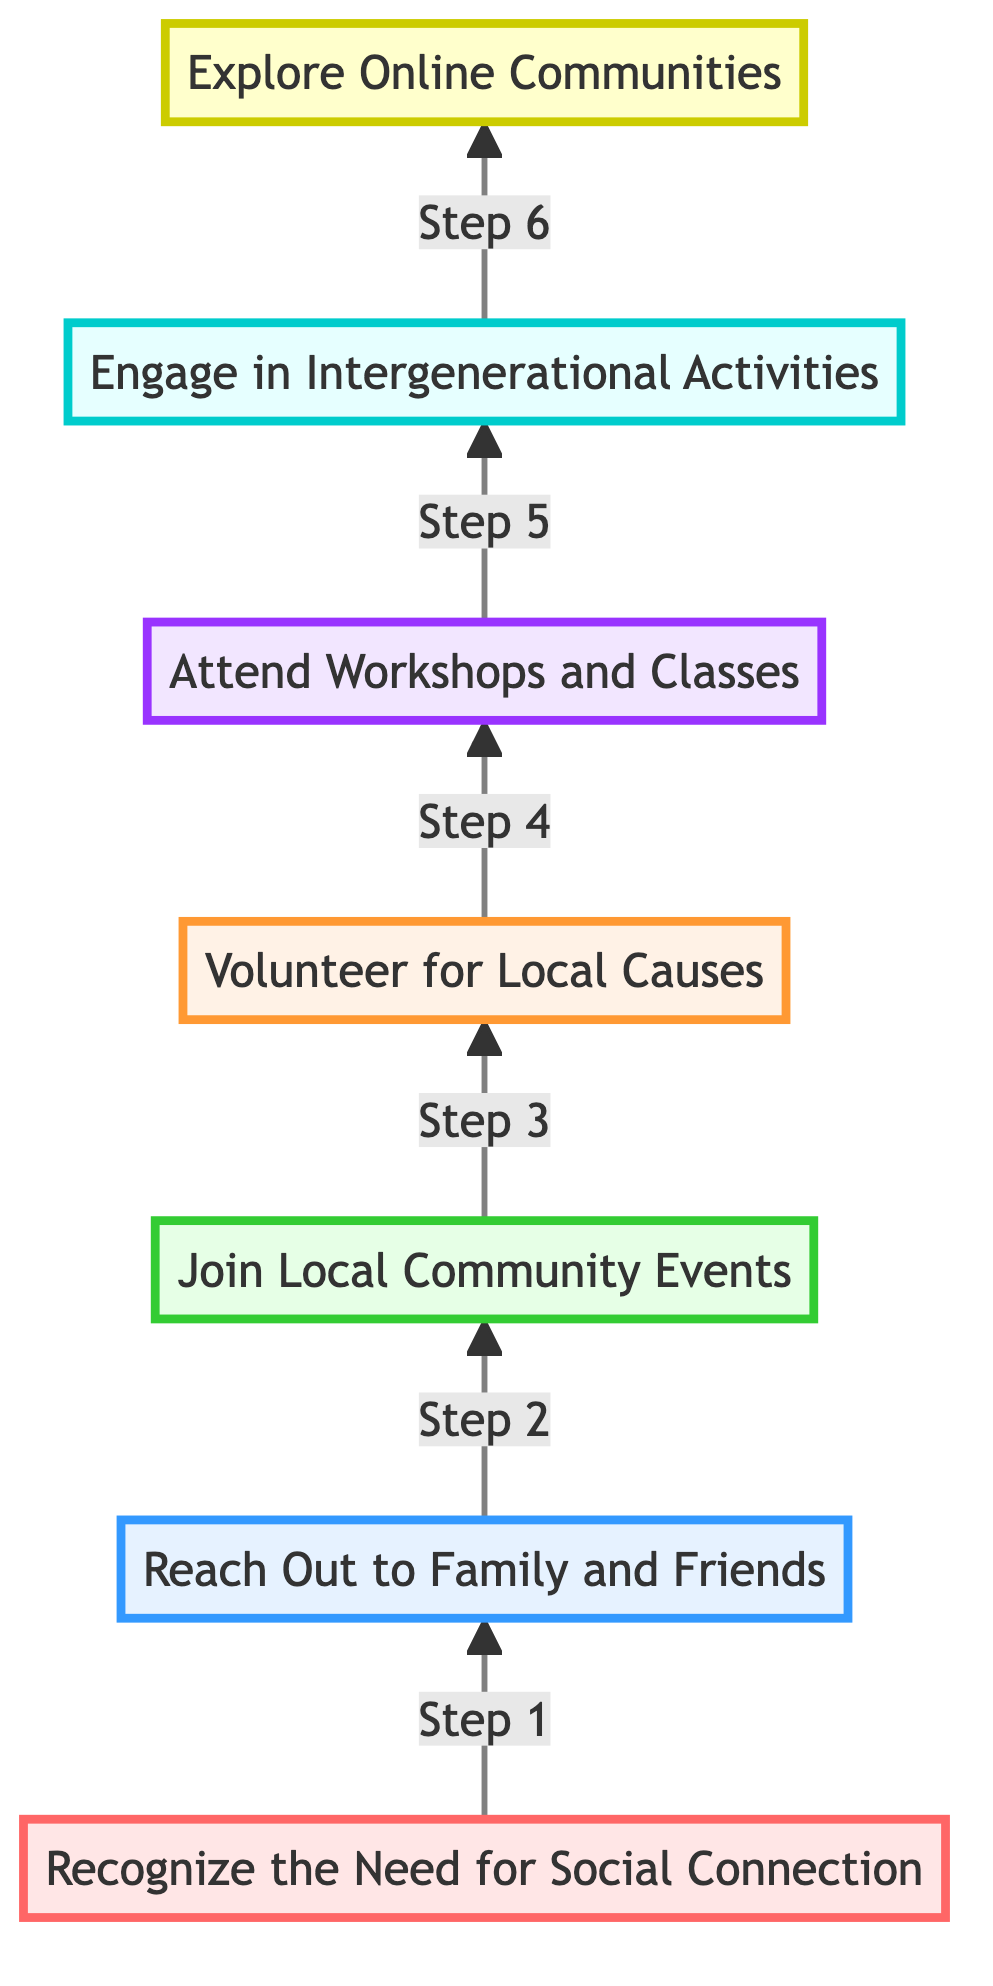What is the first step in the flow chart? The first step is labeled "Recognize the Need for Social Connection," which is the starting point in the diagram.
Answer: Recognize the Need for Social Connection How many total steps are there in the flow chart? By counting the nodes in the diagram, there are seven distinct steps that make up the process of socially connecting.
Answer: 7 What comes after "Reach Out to Family and Friends"? The step that follows "Reach Out to Family and Friends" is "Join Local Community Events," which is directly connected.
Answer: Join Local Community Events Which step involves volunteering? The step associated with volunteering is "Volunteer for Local Causes," indicating engagement in community service.
Answer: Volunteer for Local Causes What is the last step in the flow chart? The last step, located furthest up in the diagram, is "Explore Online Communities," representing the final action in the progression.
Answer: Explore Online Communities Which step is immediately before "Attend Workshops and Classes"? The step that comes immediately before "Attend Workshops and Classes" is "Volunteer for Local Causes," showing the order of participation.
Answer: Volunteer for Local Causes What level is "Engage in Intergenerational Activities"? "Engage in Intergenerational Activities" is at level 6 within the hierarchy of steps, indicating its position in the flow.
Answer: Level 6 How does one progress to "Explore Online Communities"? To reach "Explore Online Communities," one must engage in all preceding steps sequentially, leading from the initial recognition of need to active participation in various community activities.
Answer: Through all previous steps What color is the node for "Join Local Community Events"? The node representing "Join Local Community Events" has a fill color indicated as light green, distinguishing it from other steps in the diagram.
Answer: Light green 